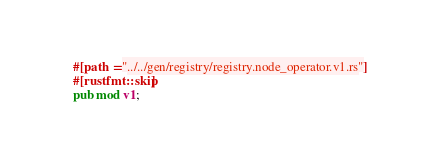Convert code to text. <code><loc_0><loc_0><loc_500><loc_500><_Rust_>#[path = "../../gen/registry/registry.node_operator.v1.rs"]
#[rustfmt::skip]
pub mod v1;
</code> 